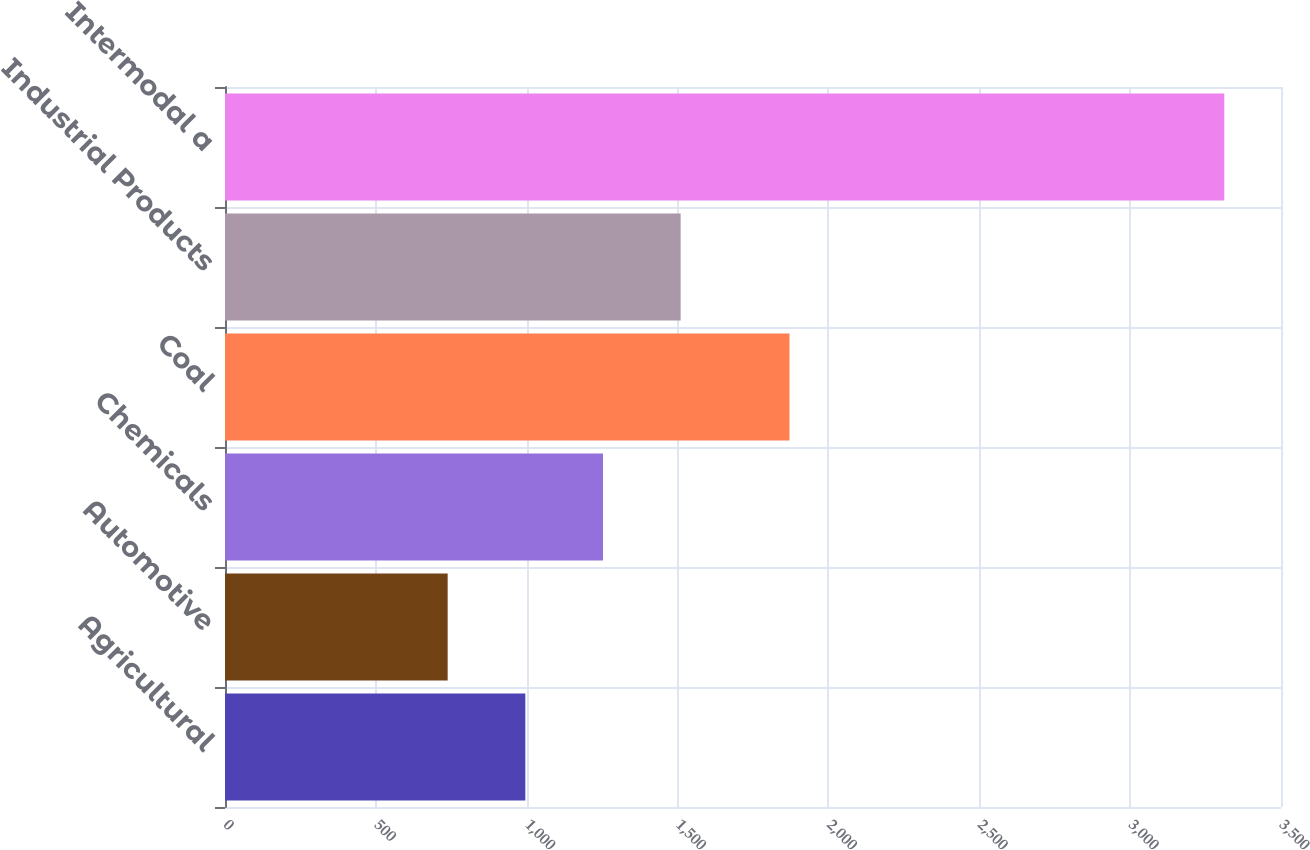<chart> <loc_0><loc_0><loc_500><loc_500><bar_chart><fcel>Agricultural<fcel>Automotive<fcel>Chemicals<fcel>Coal<fcel>Industrial Products<fcel>Intermodal a<nl><fcel>995.4<fcel>738<fcel>1252.8<fcel>1871<fcel>1510.2<fcel>3312<nl></chart> 